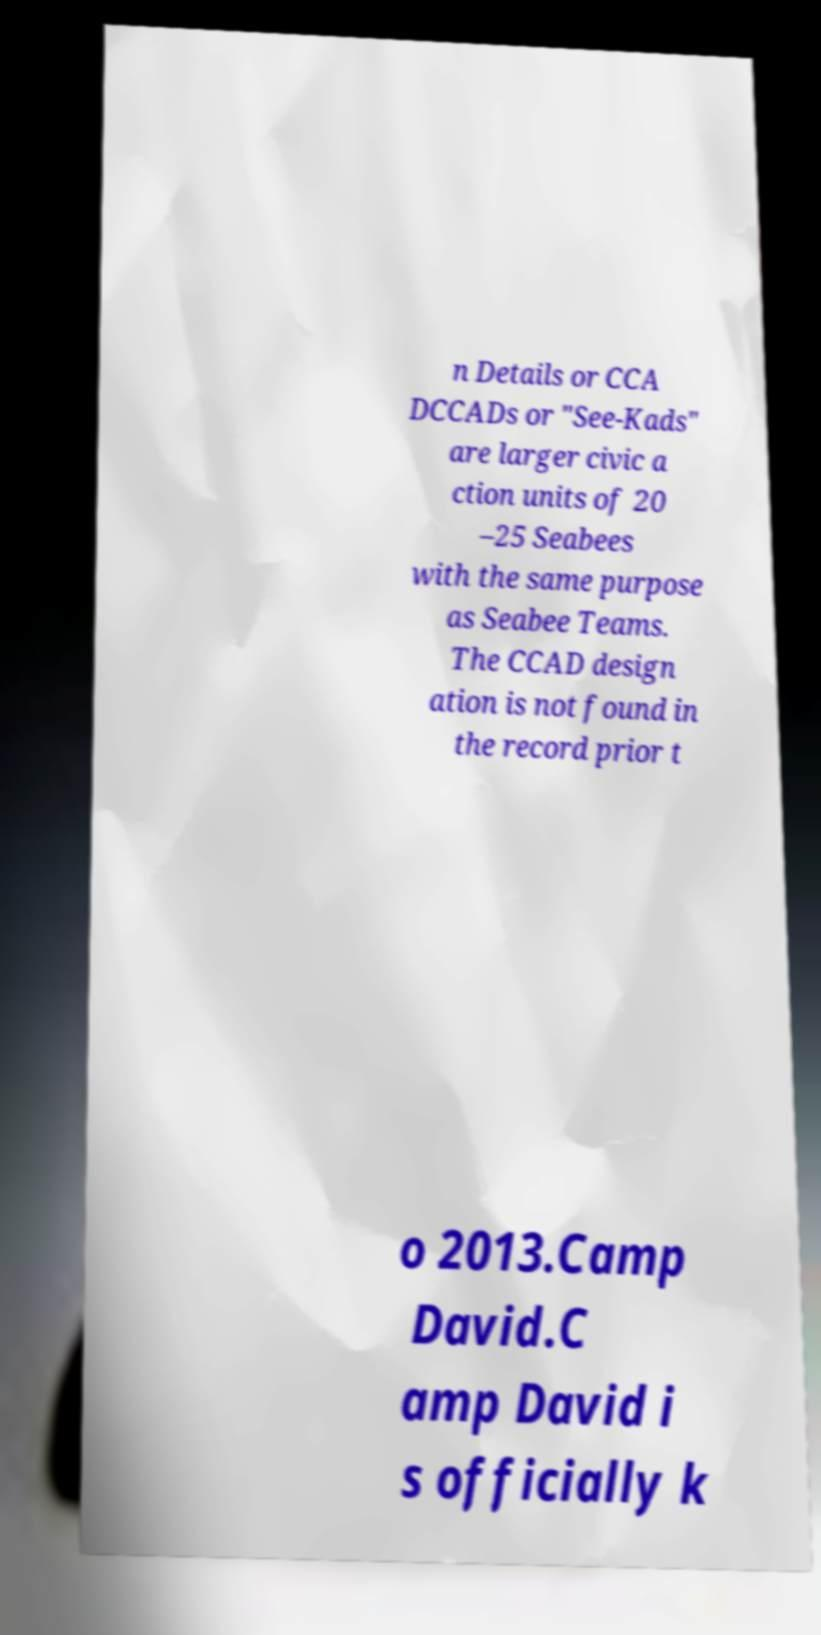What messages or text are displayed in this image? I need them in a readable, typed format. n Details or CCA DCCADs or "See-Kads" are larger civic a ction units of 20 –25 Seabees with the same purpose as Seabee Teams. The CCAD design ation is not found in the record prior t o 2013.Camp David.C amp David i s officially k 